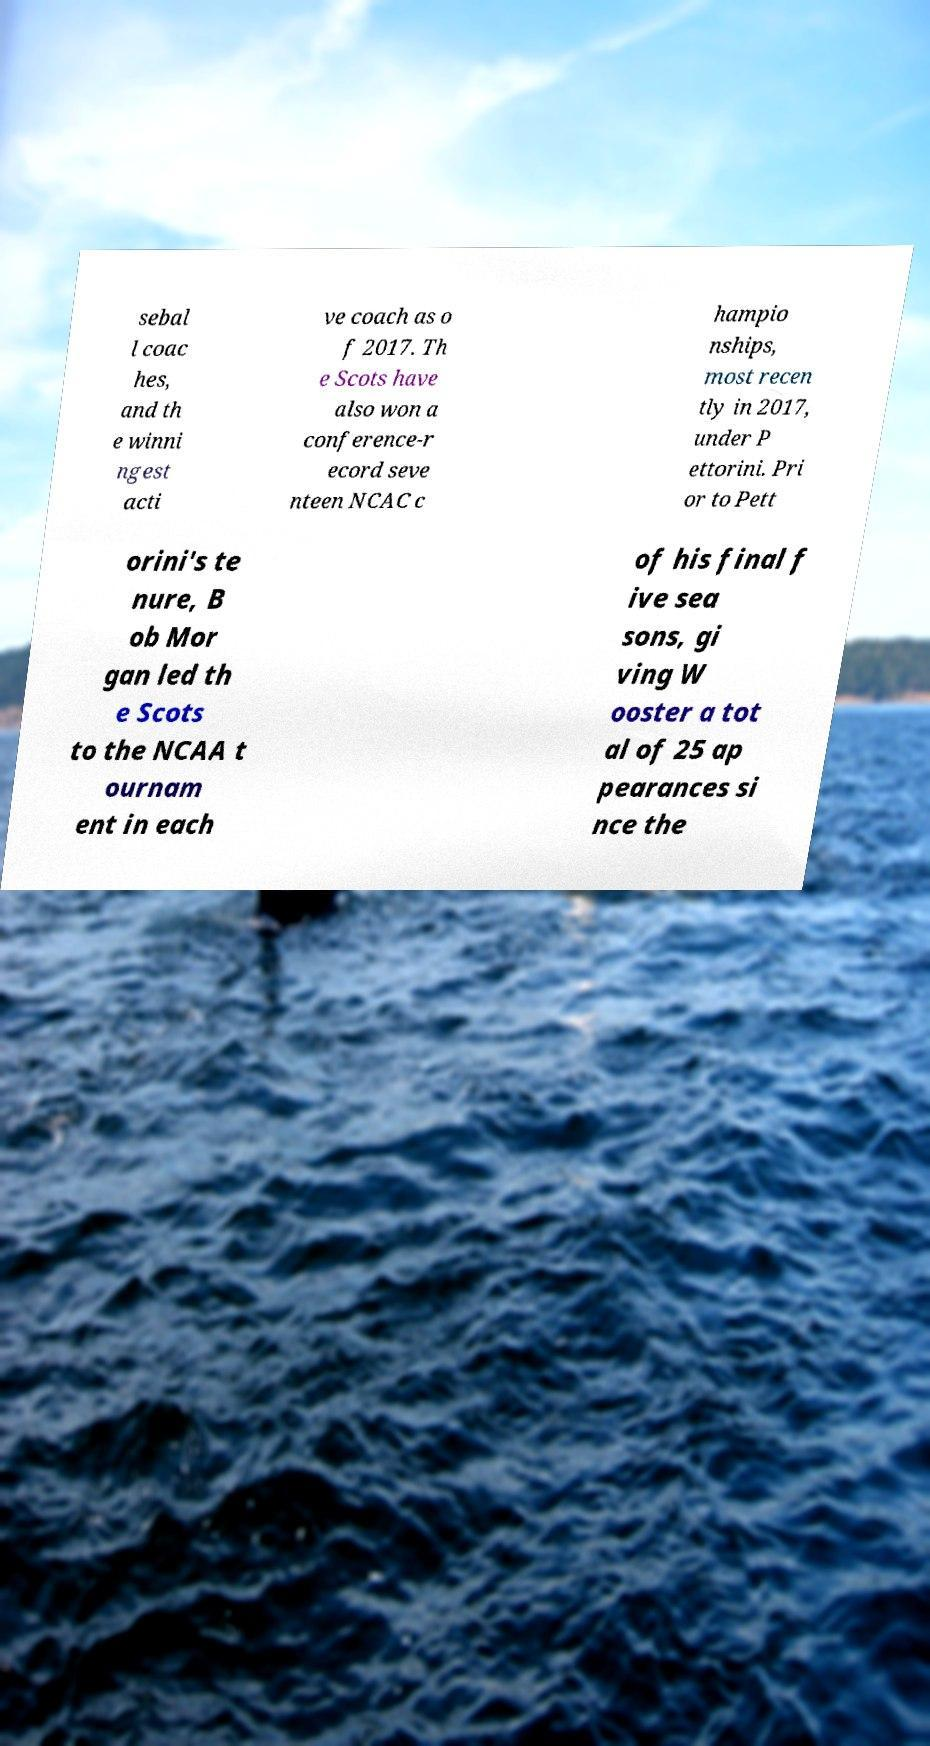Please read and relay the text visible in this image. What does it say? sebal l coac hes, and th e winni ngest acti ve coach as o f 2017. Th e Scots have also won a conference-r ecord seve nteen NCAC c hampio nships, most recen tly in 2017, under P ettorini. Pri or to Pett orini's te nure, B ob Mor gan led th e Scots to the NCAA t ournam ent in each of his final f ive sea sons, gi ving W ooster a tot al of 25 ap pearances si nce the 